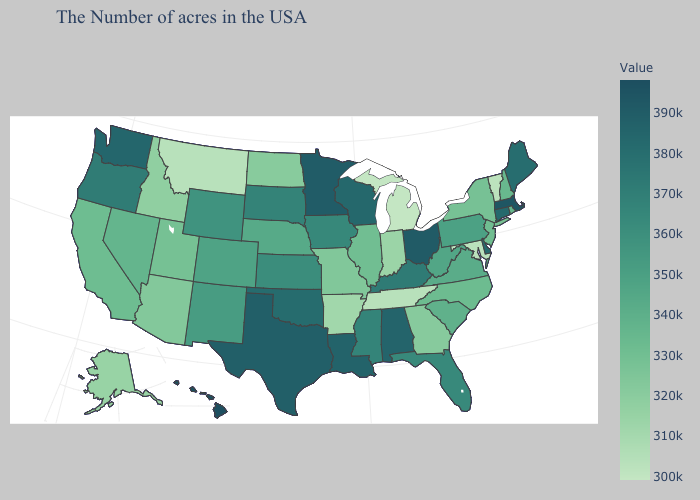Which states hav the highest value in the Northeast?
Write a very short answer. Massachusetts. Which states have the lowest value in the South?
Give a very brief answer. Maryland. Which states have the highest value in the USA?
Give a very brief answer. Hawaii. Which states hav the highest value in the West?
Concise answer only. Hawaii. Which states have the lowest value in the USA?
Quick response, please. Michigan. Which states have the highest value in the USA?
Be succinct. Hawaii. Does Hawaii have the highest value in the USA?
Short answer required. Yes. 